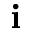Convert formula to latex. <formula><loc_0><loc_0><loc_500><loc_500>i</formula> 